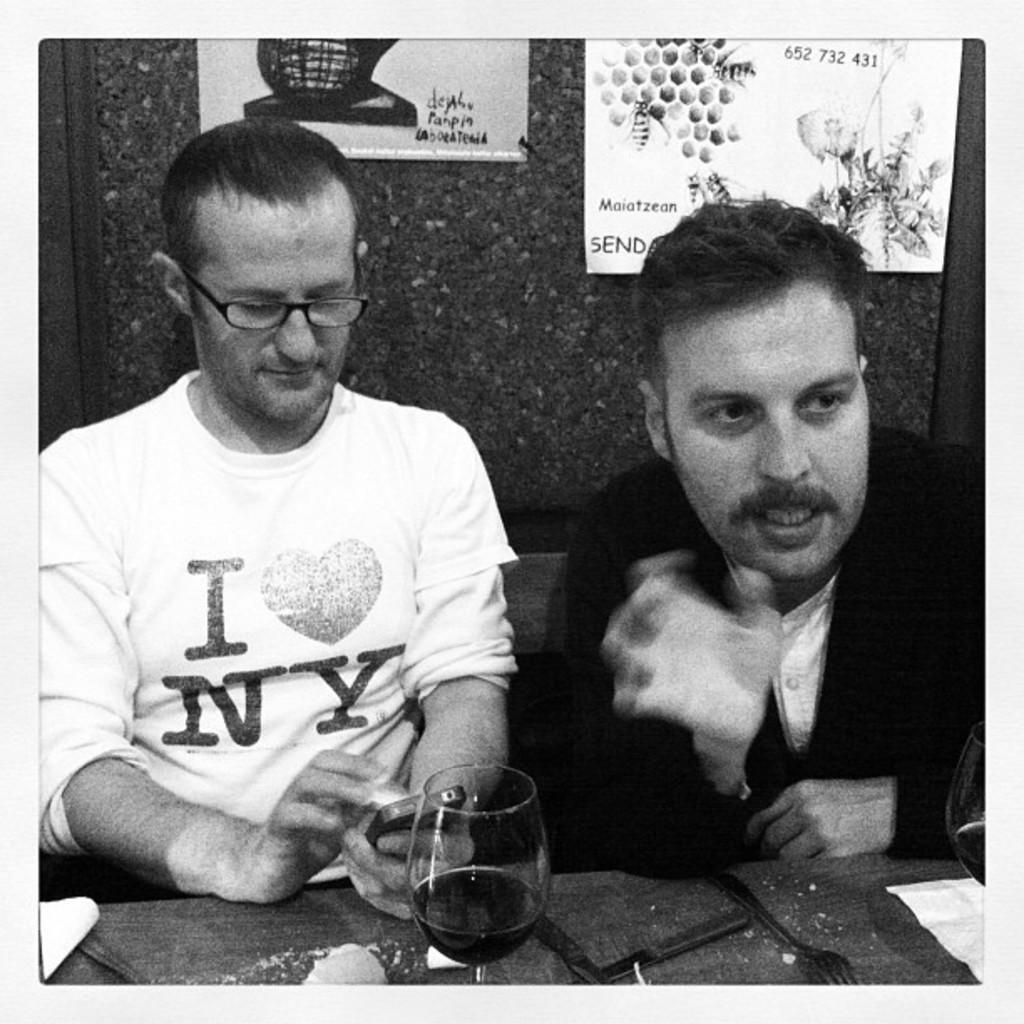How would you summarize this image in a sentence or two? This is a black and white picture. In this picture, we see two men are sitting on the chairs. The man on the right side is trying to talk something. In front of them, we see a table on which spoons, forks, tissue papers and a glass containing the liquid are placed. The man on the left side is wearing the spectacles and he is holding a mobile phone in his hands. In the background, we see a wall on which posters are pasted. 